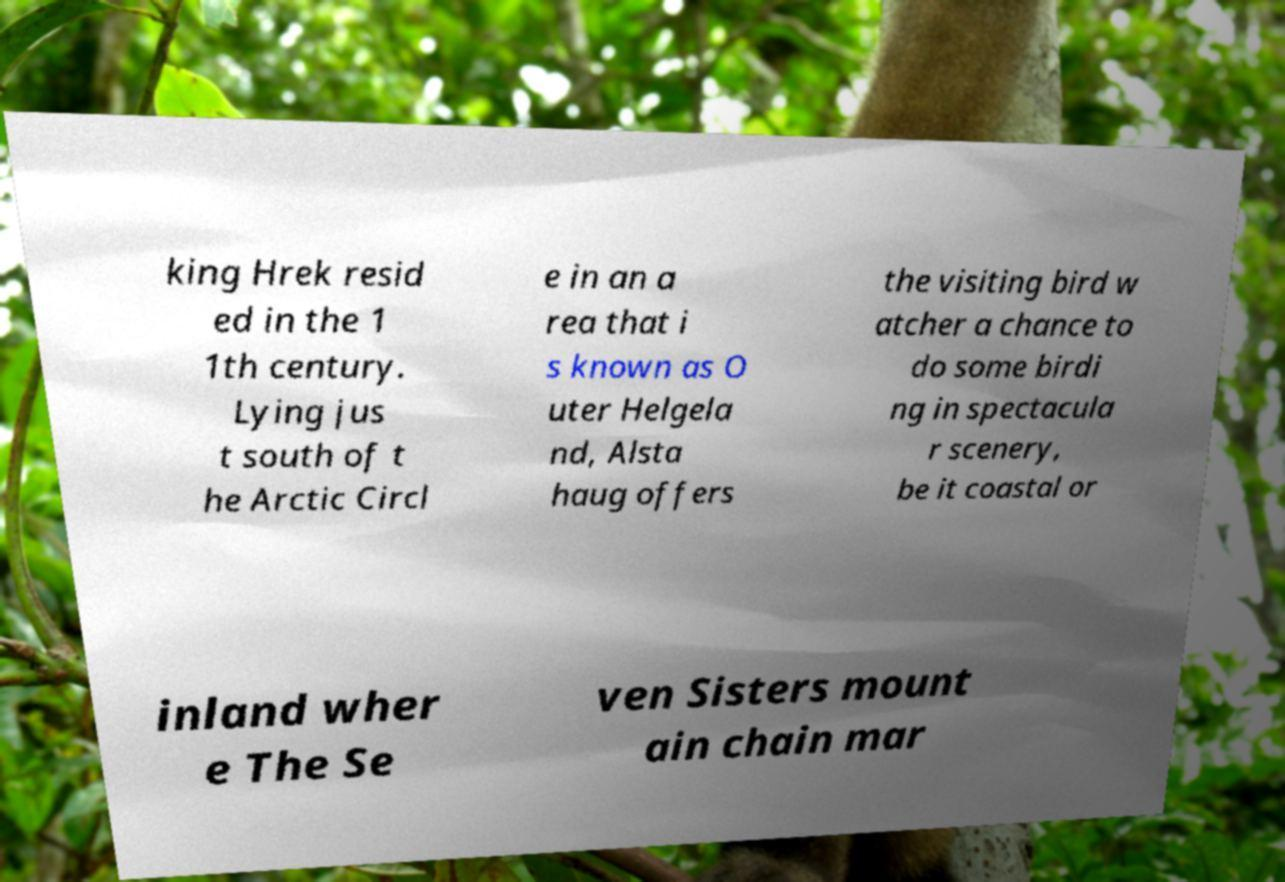Please identify and transcribe the text found in this image. king Hrek resid ed in the 1 1th century. Lying jus t south of t he Arctic Circl e in an a rea that i s known as O uter Helgela nd, Alsta haug offers the visiting bird w atcher a chance to do some birdi ng in spectacula r scenery, be it coastal or inland wher e The Se ven Sisters mount ain chain mar 